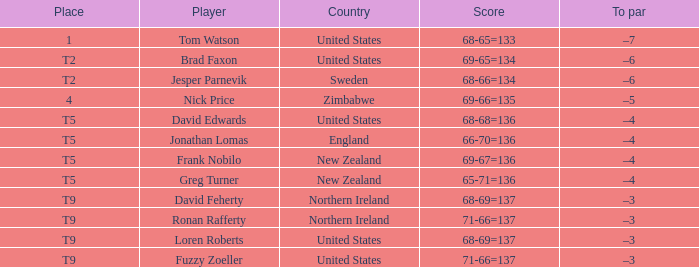Who is the golf player representing northern ireland? David Feherty, Ronan Rafferty. 